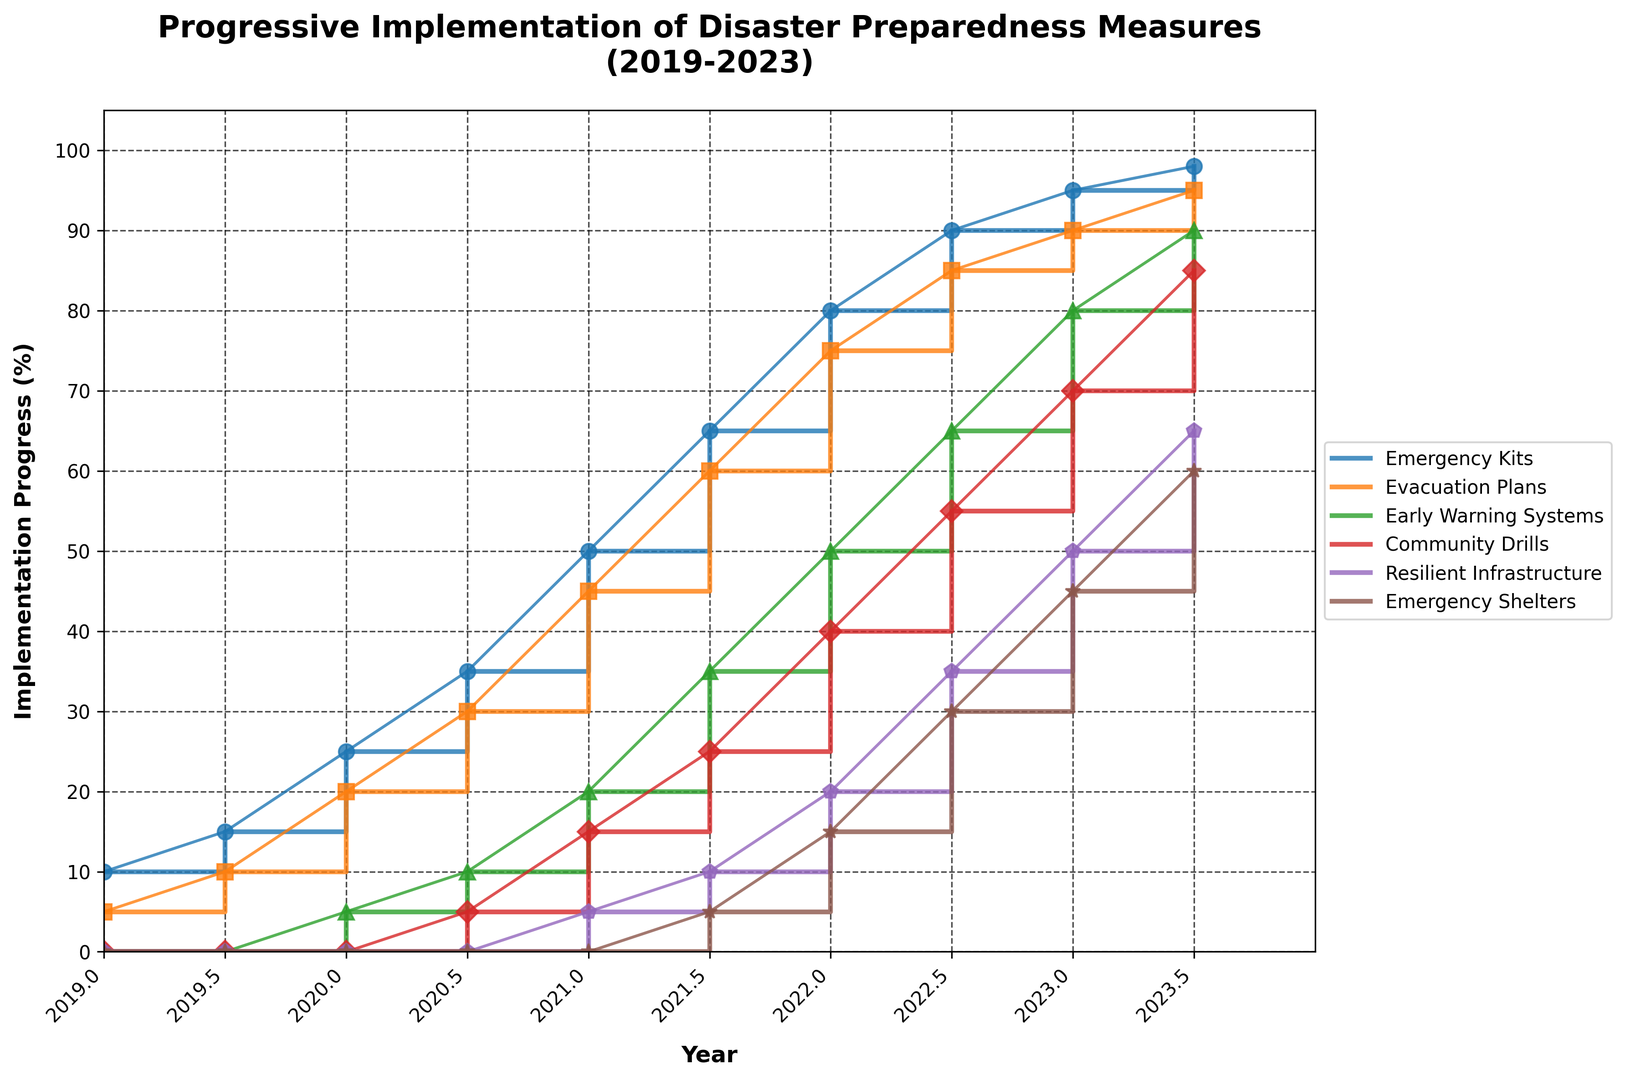What's the measure with the highest implementation progress in 2019? In 2019, "Emergency Kits" reached the highest implementation progress with 10%, while all other measures had either 0% or 5%.
Answer: Emergency Kits Between 2020.5 and 2021.5, which measure showed the greatest increase in implementation progress? From 2020.5 to 2021.5, "Emergency Kits" increased from 35% to 65%, a difference of 30%. Other measures showed smaller increases.
Answer: Emergency Kits What year did "Community Drills" first surpass 50% implementation progress? To identify the year when "Community Drills" first surpassed 50%, observe the steps in the plot for "Community Drills." In 2022, it reached 55%, surpassing 50%.
Answer: 2022 What is the total implementation progress for all measures in 2022? Sum of the implementation progress for all measures in 2022: Emergency Kits (80) + Evacuation Plans (75) + Early Warning Systems (50) + Community Drills (40) + Resilient Infrastructure (20) + Emergency Shelters (15) = 280%.
Answer: 280% By how much did "Early Warning Systems" implementation improve between 2020 and 2023.5? "Early Warning Systems" improved from 5% in 2020 to 90% in 2023.5. The difference is 90% - 5% = 85%.
Answer: 85% Which two measures had the closest implementation progress in 2020? In 2020, "Emergency Kits" and "Evacuation Plans" had the closest implementation values: Emergency Kits (25%) and Evacuation Plans (20%), a difference of 5%.
Answer: Emergency Kits and Evacuation Plans Between 2021 and 2022.5, how consistently did "Resilient Infrastructure" increase? From 2021 (5%) to 2022 (20%) to 2022.5 (35%), "Resilient Infrastructure" increased by 15% each half-year, showing consistent progress.
Answer: Consistently by 15% each half-year At the end of 2023, which measure had the lowest implementation progress, and what was its value? By the end of 2023, "Emergency Shelters" had the lowest implementation progress, showing only 45%.
Answer: Emergency Shelters How does the implementation progress of "Evacuation Plans" in 2021 compare to that of "Community Drills" in the same year? In 2021, "Evacuation Plans" had a progress of 45%, while "Community Drills" had a progress of 15%. "Evacuation Plans" was higher by 30%.
Answer: "Evacuation Plans" was higher by 30% What is the average implementation progress of "Resilient Infrastructure" over the 5-year period? The implementation progress of "Resilient Infrastructure" over the years: 0%, 0%, 5%, 10%, 20%, 35%, 50%, 65%. The average is (0 + 0 + 5 + 10 + 20 + 35 + 50 + 65) / 8 = 185 / 8 = 23.125.
Answer: 23.125% 